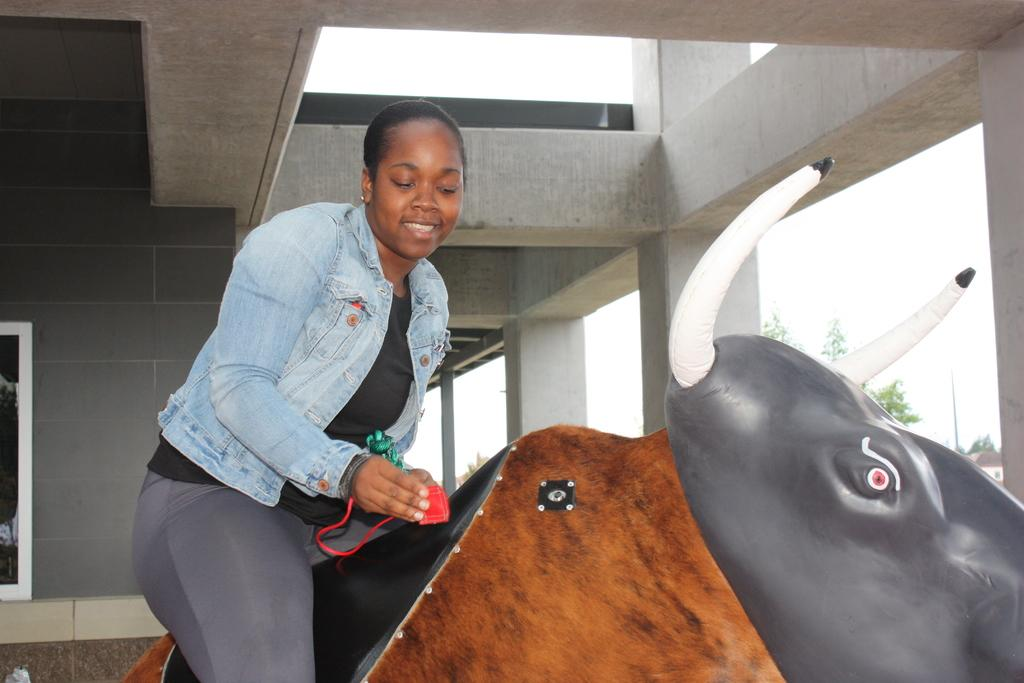What is the lady in the image sitting on? The lady is sitting on a plastic bull. What is the lady holding in the image? The lady is holding a rope. What type of structures can be seen in the image? There are pillars, a wall, and windows visible in the image. What type of vegetation is present in the image? There are trees in the image. What other object can be seen in the image? There is a pole in the image. What part of the natural environment is visible in the image? The sky is visible in the image. What type of noise can be heard coming from the boats in the image? There are no boats present in the image, so it's not possible to determine what, if any, noise might be heard. 